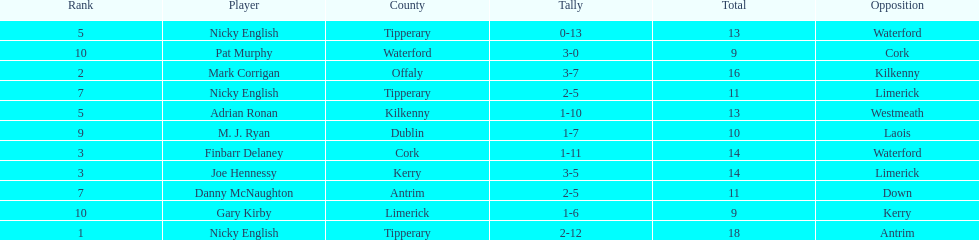What player got 10 total points in their game? M. J. Ryan. 